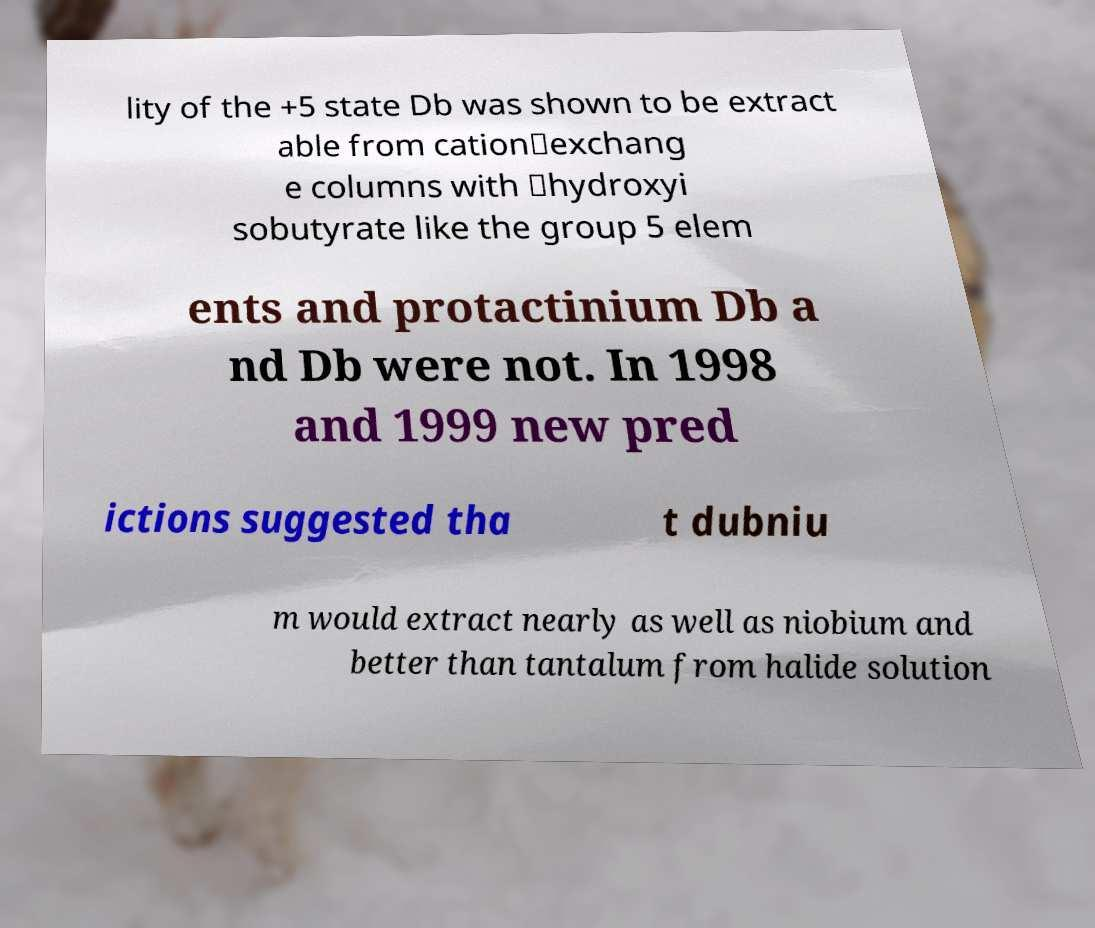Please identify and transcribe the text found in this image. lity of the +5 state Db was shown to be extract able from cation‐exchang e columns with ‐hydroxyi sobutyrate like the group 5 elem ents and protactinium Db a nd Db were not. In 1998 and 1999 new pred ictions suggested tha t dubniu m would extract nearly as well as niobium and better than tantalum from halide solution 